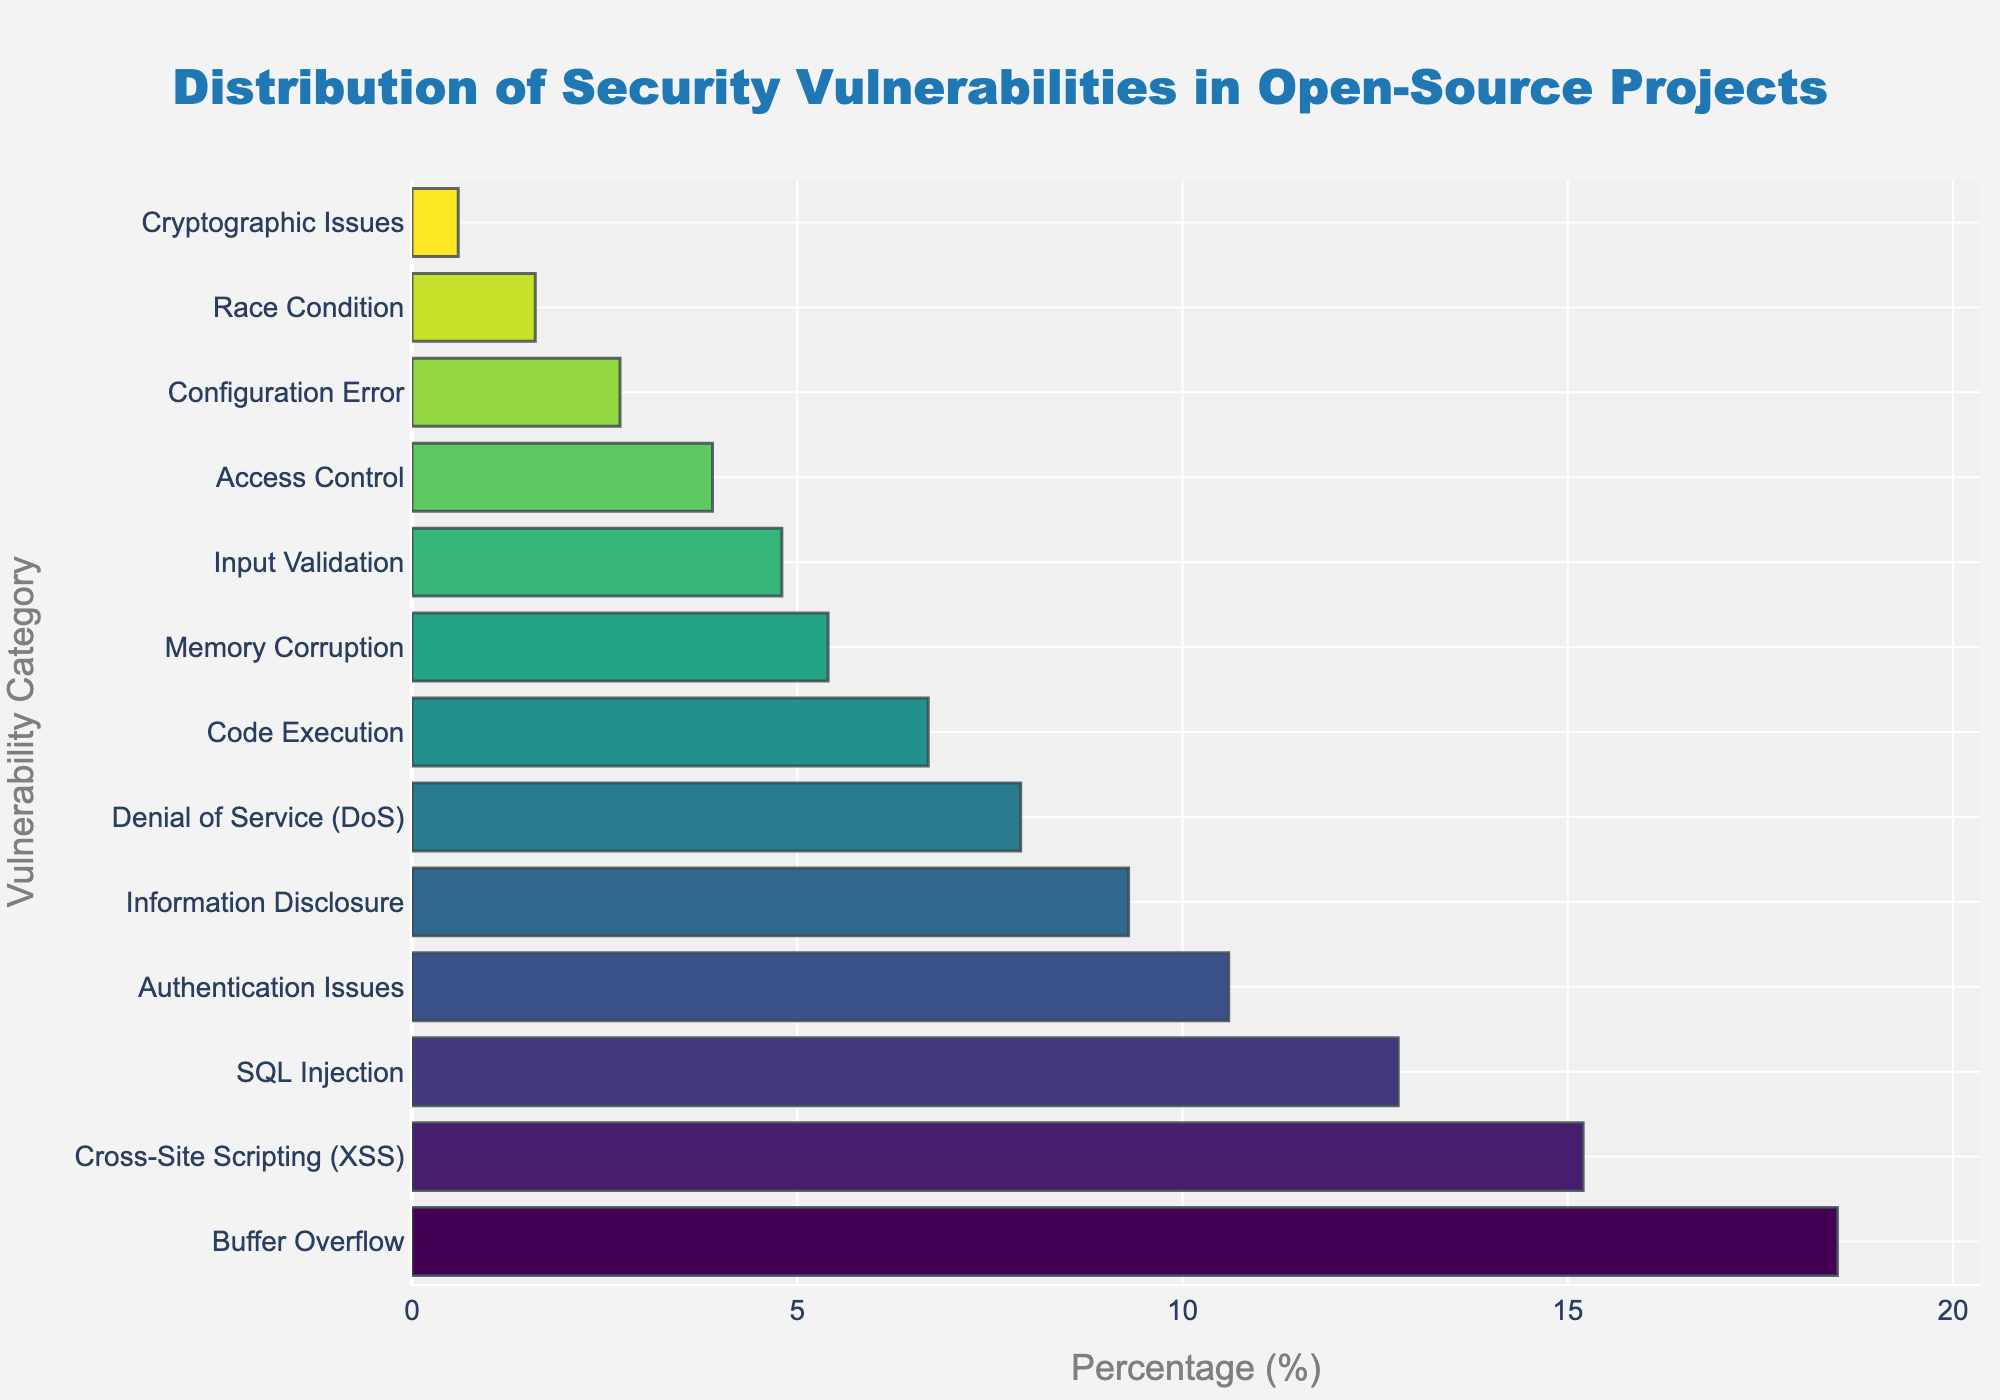What category has the highest percentage of security vulnerabilities? By looking at the length of the bars, the first category, "Buffer Overflow", has the longest bar, thus the highest percentage.
Answer: Buffer Overflow Which two categories combined have a percentage close to 20%? "Denial of Service (DoS)" has a percentage of 7.9% and "Code Execution" has 6.7%. Summing these gives 7.9 + 6.7 = 14.6, which is close to 20%.
Answer: Denial of Service (DoS) and Code Execution How does the percentage of Information Disclosure compare to that of Input Validation? Information Disclosure has a percentage of 9.3%, while Input Validation has 4.8%. Thus, Information Disclosure is higher.
Answer: Information Disclosure is higher What are the percentages of all categories with less than 5%? The categories below 5% are "Memory Corruption" (5.4%), "Input Validation" (4.8%), "Access Control" (3.9%), "Configuration Error" (2.7%), "Race Condition" (1.6%), and "Cryptographic Issues" (0.6%).
Answer: 5.4%, 4.8%, 3.9%, 2.7%, 1.6%, 0.6% Which category is immediately below “SQL Injection” in terms of percentage? The category listed immediately below "SQL Injection" (12.8%) is "Authentication Issues" (10.6%), based on their order in the chart.
Answer: Authentication Issues What is the percentage difference between Cross-Site Scripting (XSS) and Authentication Issues? Cross-Site Scripting (XSS) is 15.2% and Authentication Issues is 10.6%. Subtracting these gives 15.2 - 10.6 = 4.6%.
Answer: 4.6% Which category's bar is closer in length to the average length of all bars? To find the average length, sum all percentages and divide by the number of categories: (18.5 + 15.2 + 12.8 + 10.6 + 9.3 + 7.9 + 6.7 + 5.4 + 4.8 + 3.9 + 2.7 + 1.6 + 0.6) / 13 = 99.0 / 13 ≈ 7.6%. "Denial of Service (DoS)" at 7.9% is closest to this average.
Answer: Denial of Service (DoS) What is the combined percentage of the top three vulnerability categories? The top three categories are "Buffer Overflow" (18.5%), "Cross-Site Scripting (XSS)" (15.2%), and "SQL Injection" (12.8%). Summing these gives 18.5 + 15.2 + 12.8 = 46.5%.
Answer: 46.5% Which category has the shortest bar in the chart? The shortest bar represents "Cryptographic Issues" with a percentage of 0.6%.
Answer: Cryptographic Issues What is the percentage range of the top five categories? The top five categories are "Buffer Overflow" (18.5%), "Cross-Site Scripting (XSS)" (15.2%), "SQL Injection" (12.8%), "Authentication Issues" (10.6%), and "Information Disclosure" (9.3%). The range is calculated as the difference between the highest and lowest percentages: 18.5 - 9.3 = 9.2%.
Answer: 9.2% 